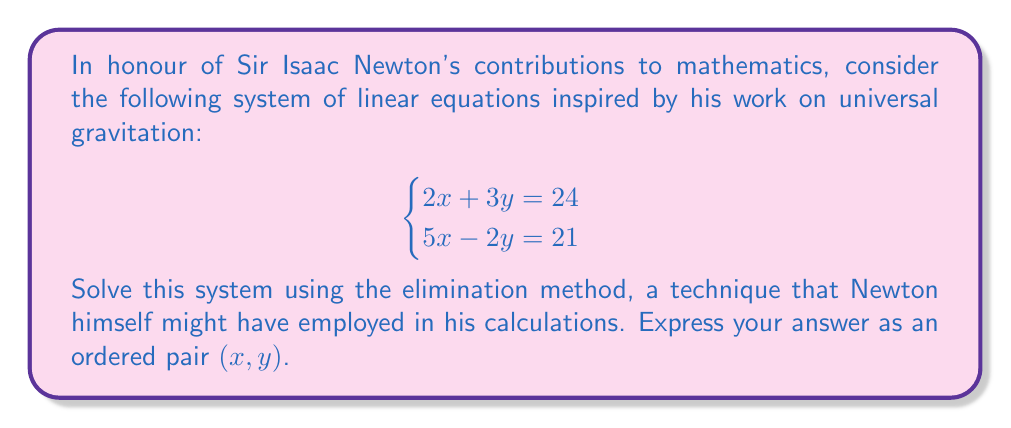Could you help me with this problem? Let's solve this system step-by-step using the elimination method:

1) First, we need to eliminate one of the variables. Let's choose to eliminate y. To do this, we'll multiply the first equation by 2 and the second equation by 3:

   Equation 1: $2(2x + 3y = 24)$ gives $4x + 6y = 48$
   Equation 2: $3(5x - 2y = 21)$ gives $15x - 6y = 63$

2) Now we can add these equations to eliminate y:

   $(4x + 6y) + (15x - 6y) = 48 + 63$
   $19x = 111$

3) Solve for x:

   $x = \frac{111}{19}$

4) Now that we know x, we can substitute this value into either of the original equations to find y. Let's use the first equation:

   $2(\frac{111}{19}) + 3y = 24$

5) Simplify:

   $\frac{222}{19} + 3y = 24$

6) Subtract $\frac{222}{19}$ from both sides:

   $3y = 24 - \frac{222}{19} = \frac{456}{19} - \frac{222}{19} = \frac{234}{19}$

7) Solve for y:

   $y = \frac{234}{57} = \frac{78}{19}$

Therefore, the solution is $x = \frac{111}{19}$ and $y = \frac{78}{19}$.
Answer: $(\frac{111}{19}, \frac{78}{19})$ 